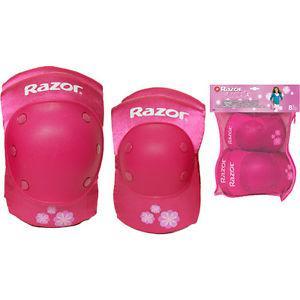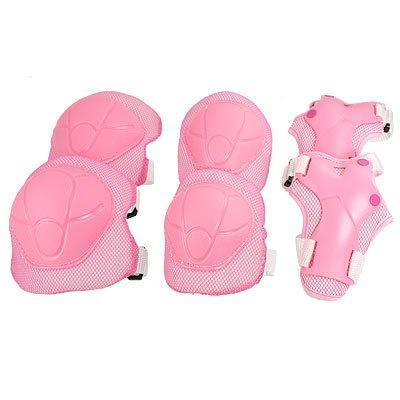The first image is the image on the left, the second image is the image on the right. For the images shown, is this caption "In at least one of the images, we see only knee pads; no elbow pads or gloves." true? Answer yes or no. No. 